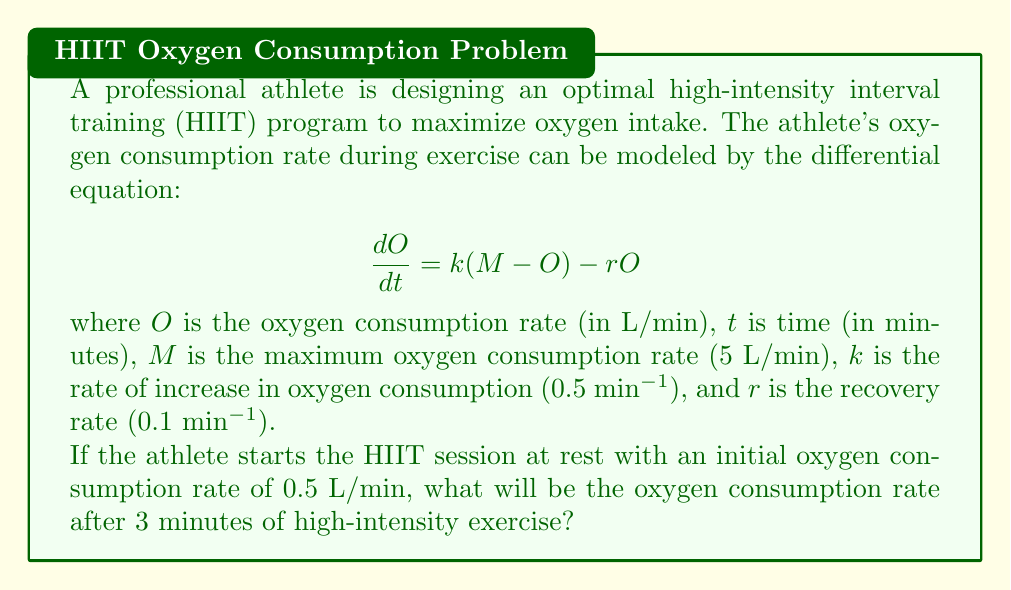Help me with this question. To solve this problem, we need to follow these steps:

1. Identify the given differential equation and initial condition:
   $$\frac{dO}{dt} = k(M - O) - rO$$
   $$O(0) = 0.5 \text{ L/min}$$

2. Rearrange the equation:
   $$\frac{dO}{dt} = kM - kO - rO = kM - (k+r)O$$

3. This is a first-order linear differential equation of the form:
   $$\frac{dO}{dt} + (k+r)O = kM$$

4. The general solution for this type of equation is:
   $$O(t) = Ce^{-(k+r)t} + \frac{kM}{k+r}$$
   where $C$ is a constant to be determined by the initial condition.

5. Substitute the given values:
   $k = 0.5 \text{ min}^{-1}$, $r = 0.1 \text{ min}^{-1}$, $M = 5 \text{ L/min}$

6. Calculate $\frac{kM}{k+r}$:
   $$\frac{kM}{k+r} = \frac{0.5 \cdot 5}{0.5 + 0.1} = \frac{2.5}{0.6} \approx 4.17 \text{ L/min}$$

7. Use the initial condition to find $C$:
   $$0.5 = Ce^{-(0.5+0.1)\cdot0} + 4.17$$
   $$C = 0.5 - 4.17 = -3.67$$

8. The complete solution is:
   $$O(t) = -3.67e^{-0.6t} + 4.17$$

9. Calculate the oxygen consumption rate at $t = 3$ minutes:
   $$O(3) = -3.67e^{-0.6 \cdot 3} + 4.17$$
   $$O(3) = -3.67e^{-1.8} + 4.17$$
   $$O(3) = -3.67 \cdot 0.1653 + 4.17$$
   $$O(3) = -0.6066 + 4.17 = 3.5634 \text{ L/min}$$
Answer: The oxygen consumption rate after 3 minutes of high-intensity exercise will be approximately 3.56 L/min. 